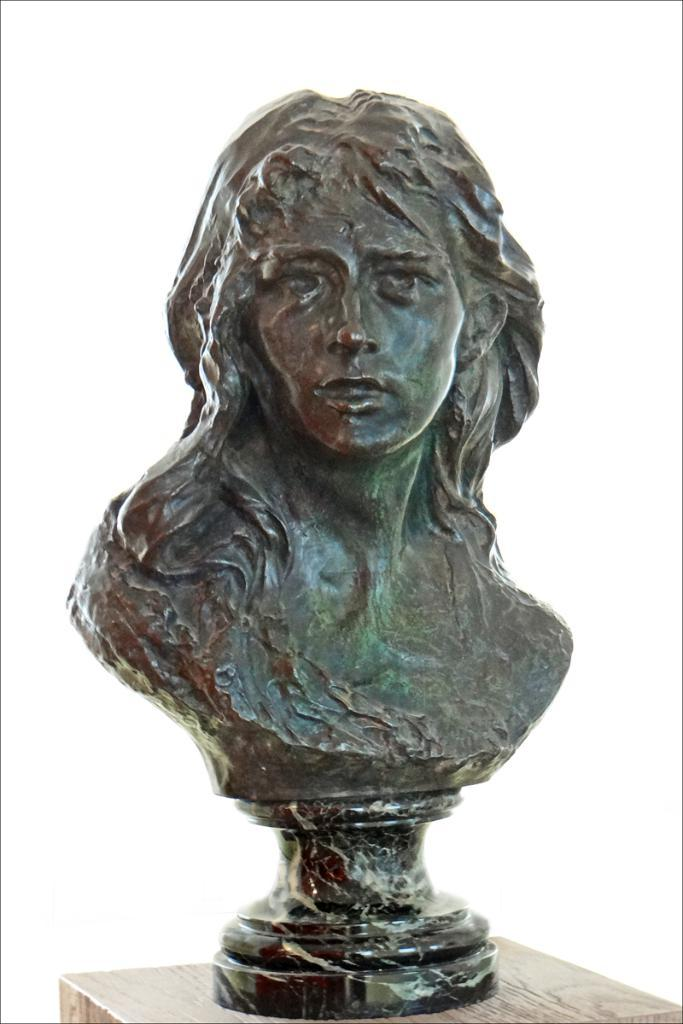What is the main subject of the image? The main subject of the image is a sculpture. Can you describe the sculpture's base? The sculpture is on a wooden stand. What type of chess piece is depicted in the sculpture? There is no chess piece present in the image; it is a sculpture on a wooden stand. How many steps are visible in the image? There are no steps present in the image; it features a sculpture on a wooden stand. 